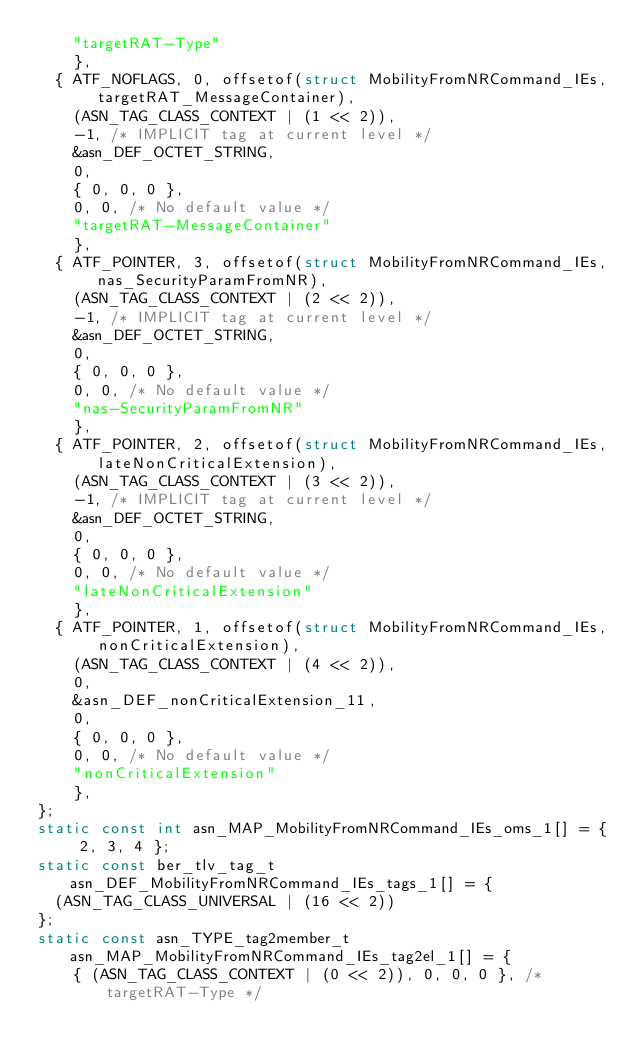<code> <loc_0><loc_0><loc_500><loc_500><_C_>		"targetRAT-Type"
		},
	{ ATF_NOFLAGS, 0, offsetof(struct MobilityFromNRCommand_IEs, targetRAT_MessageContainer),
		(ASN_TAG_CLASS_CONTEXT | (1 << 2)),
		-1,	/* IMPLICIT tag at current level */
		&asn_DEF_OCTET_STRING,
		0,
		{ 0, 0, 0 },
		0, 0, /* No default value */
		"targetRAT-MessageContainer"
		},
	{ ATF_POINTER, 3, offsetof(struct MobilityFromNRCommand_IEs, nas_SecurityParamFromNR),
		(ASN_TAG_CLASS_CONTEXT | (2 << 2)),
		-1,	/* IMPLICIT tag at current level */
		&asn_DEF_OCTET_STRING,
		0,
		{ 0, 0, 0 },
		0, 0, /* No default value */
		"nas-SecurityParamFromNR"
		},
	{ ATF_POINTER, 2, offsetof(struct MobilityFromNRCommand_IEs, lateNonCriticalExtension),
		(ASN_TAG_CLASS_CONTEXT | (3 << 2)),
		-1,	/* IMPLICIT tag at current level */
		&asn_DEF_OCTET_STRING,
		0,
		{ 0, 0, 0 },
		0, 0, /* No default value */
		"lateNonCriticalExtension"
		},
	{ ATF_POINTER, 1, offsetof(struct MobilityFromNRCommand_IEs, nonCriticalExtension),
		(ASN_TAG_CLASS_CONTEXT | (4 << 2)),
		0,
		&asn_DEF_nonCriticalExtension_11,
		0,
		{ 0, 0, 0 },
		0, 0, /* No default value */
		"nonCriticalExtension"
		},
};
static const int asn_MAP_MobilityFromNRCommand_IEs_oms_1[] = { 2, 3, 4 };
static const ber_tlv_tag_t asn_DEF_MobilityFromNRCommand_IEs_tags_1[] = {
	(ASN_TAG_CLASS_UNIVERSAL | (16 << 2))
};
static const asn_TYPE_tag2member_t asn_MAP_MobilityFromNRCommand_IEs_tag2el_1[] = {
    { (ASN_TAG_CLASS_CONTEXT | (0 << 2)), 0, 0, 0 }, /* targetRAT-Type */</code> 